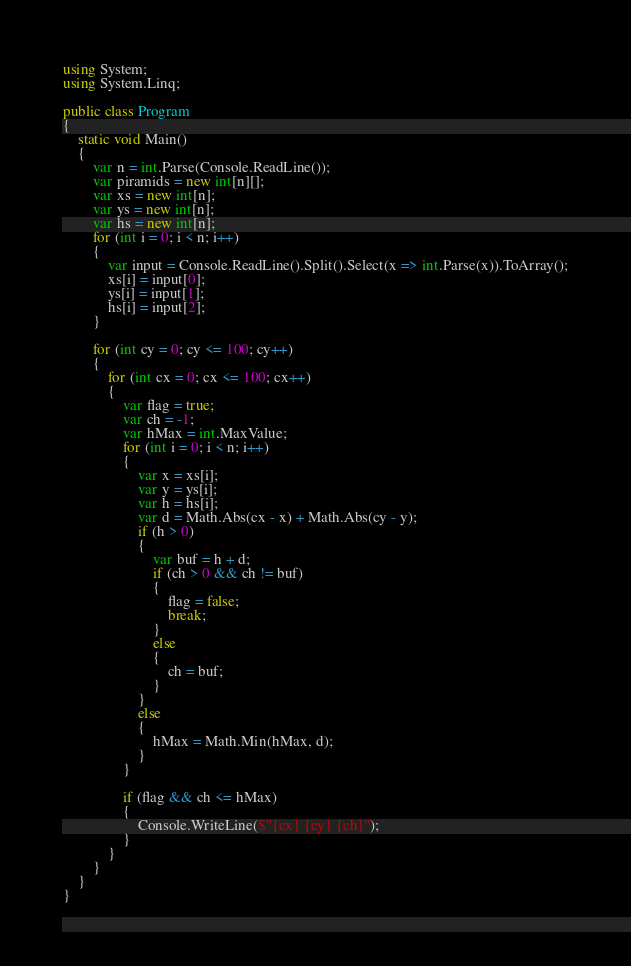Convert code to text. <code><loc_0><loc_0><loc_500><loc_500><_C#_>using System;
using System.Linq;

public class Program
{
    static void Main()
    {
        var n = int.Parse(Console.ReadLine());
        var piramids = new int[n][];
        var xs = new int[n];
        var ys = new int[n];
        var hs = new int[n];
        for (int i = 0; i < n; i++)
        {
            var input = Console.ReadLine().Split().Select(x => int.Parse(x)).ToArray();
            xs[i] = input[0];
            ys[i] = input[1];
            hs[i] = input[2];
        }

        for (int cy = 0; cy <= 100; cy++)
        {
            for (int cx = 0; cx <= 100; cx++)
            {
                var flag = true;
                var ch = -1;
                var hMax = int.MaxValue;
                for (int i = 0; i < n; i++)
                {
                    var x = xs[i];
                    var y = ys[i];
                    var h = hs[i];
                    var d = Math.Abs(cx - x) + Math.Abs(cy - y);
                    if (h > 0)
                    {
                        var buf = h + d;
                        if (ch > 0 && ch != buf)
                        {
                            flag = false;
                            break;
                        }
                        else
                        {
                            ch = buf;
                        }
                    }
                    else
                    {
                        hMax = Math.Min(hMax, d);
                    }
                }

                if (flag && ch <= hMax)
                {
                    Console.WriteLine($"{cx} {cy} {ch}");
                }
            }
        }
    }
}
</code> 